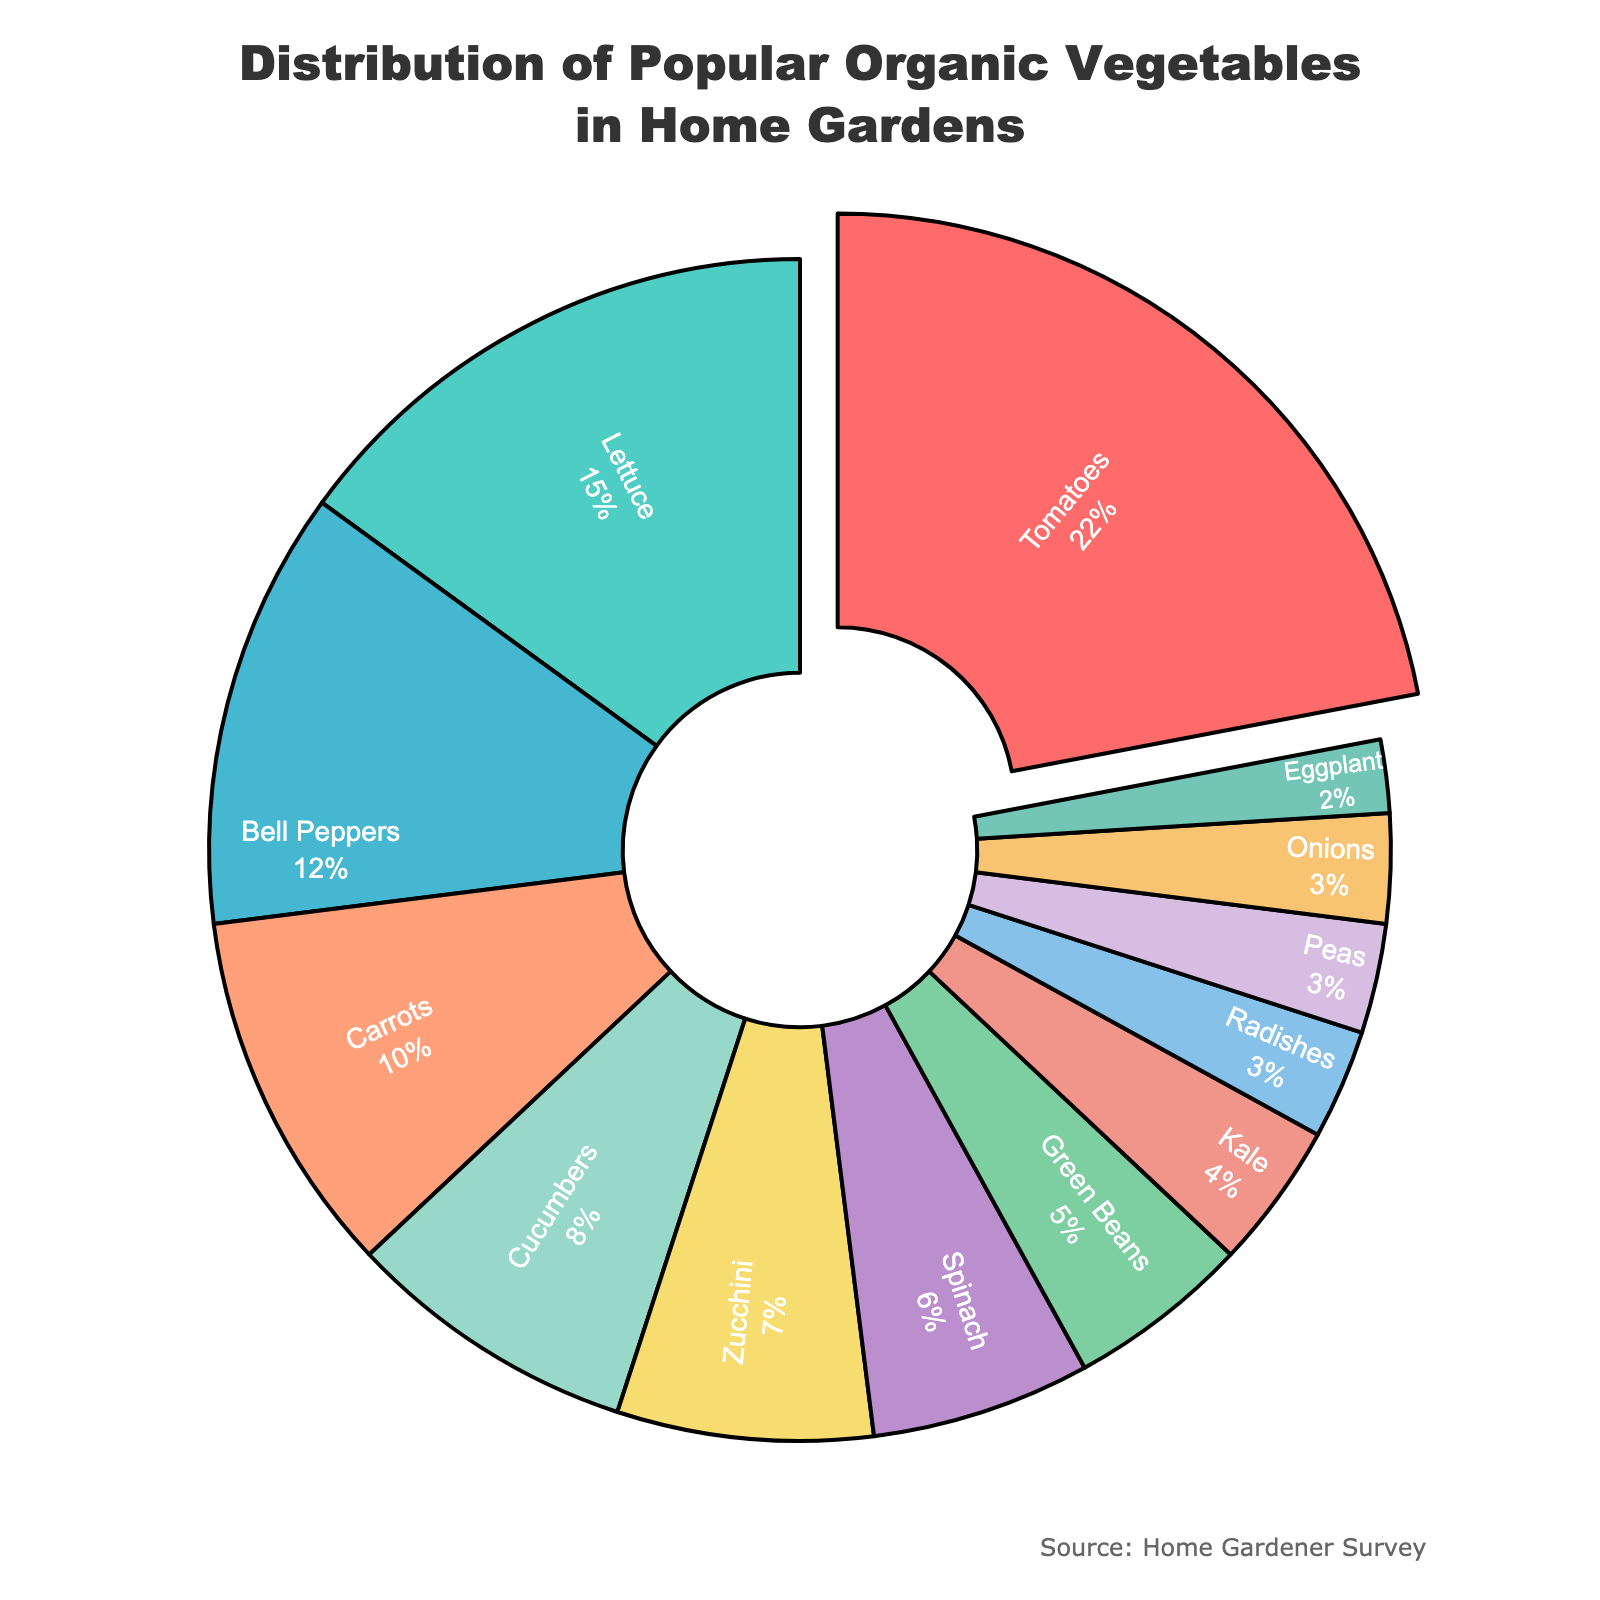What's the most popular organic vegetable grown in home gardens? The figure shows a pie chart with various vegetables and their percentages. The vegetable with the largest slice is Tomatoes, which has a percentage value of 22%. Therefore, Tomatoes are the most popular.
Answer: Tomatoes Which vegetables together make up more than 50% of the total distribution? By summing the percentages from the largest slices downward until the total exceeds 50%, we first add Tomatoes (22%), then Lettuce (15%), and Bell Peppers (12%). This sums to 49%. Including Carrots (10%) brings the cumulative percentage to 59%, which exceeds 50%.
Answer: Tomatoes, Lettuce, Bell Peppers, Carrots What percentage of home gardeners grow Peas, Onions, and Eggplant combined? The percentage for Peas is 3%, Onions is 3%, and Eggplant is 2%. Adding these percentages gives 3 + 3 + 2 = 8%.
Answer: 8% Is the percentage of gardeners growing Zucchini greater than those growing Spinach? The chart shows Zucchini with a percentage of 7% and Spinach with 6%. Since 7% is greater than 6%, more gardeners grow Zucchini than Spinach.
Answer: Yes How much more popular are Bell Peppers compared to Cucumbers? The percentage for Bell Peppers is 12% and for Cucumbers is 8%. Subtracting these gives 12 - 8 = 4%. Bell Peppers are 4% more popular than Cucumbers.
Answer: 4% What percentage is taken up by all the leafy greens together (Lettuce, Spinach, Kale)? Lettuce has a percentage of 15%, Spinach 6%, and Kale 4%. Adding these together gives 15 + 6 + 4 = 25%.
Answer: 25% Which vegetable has the smallest slice of the pie chart? The vegetable with the smallest percentage is Eggplant, which has 2%. This is the smallest slice in the pie chart.
Answer: Eggplant Do Carrots and Lettuce together account for more than Bell Peppers and Cucumbers combined? Adding Carrots (10%) and Lettuce (15%) gives 25%. Adding Bell Peppers (12%) and Cucumbers (8%) gives 20%. Since 25% is greater than 20%, Carrots and Lettuce together account for more.
Answer: Yes How many vegetables have a percentage of 5% or less? The vegetables with percentages of 5% or less are Green Beans (5%), Kale (4%), Radishes (3%), Peas (3%), Onions (3%), and Eggplant (2%). There are 6 vegetables with 5% or less.
Answer: 6 